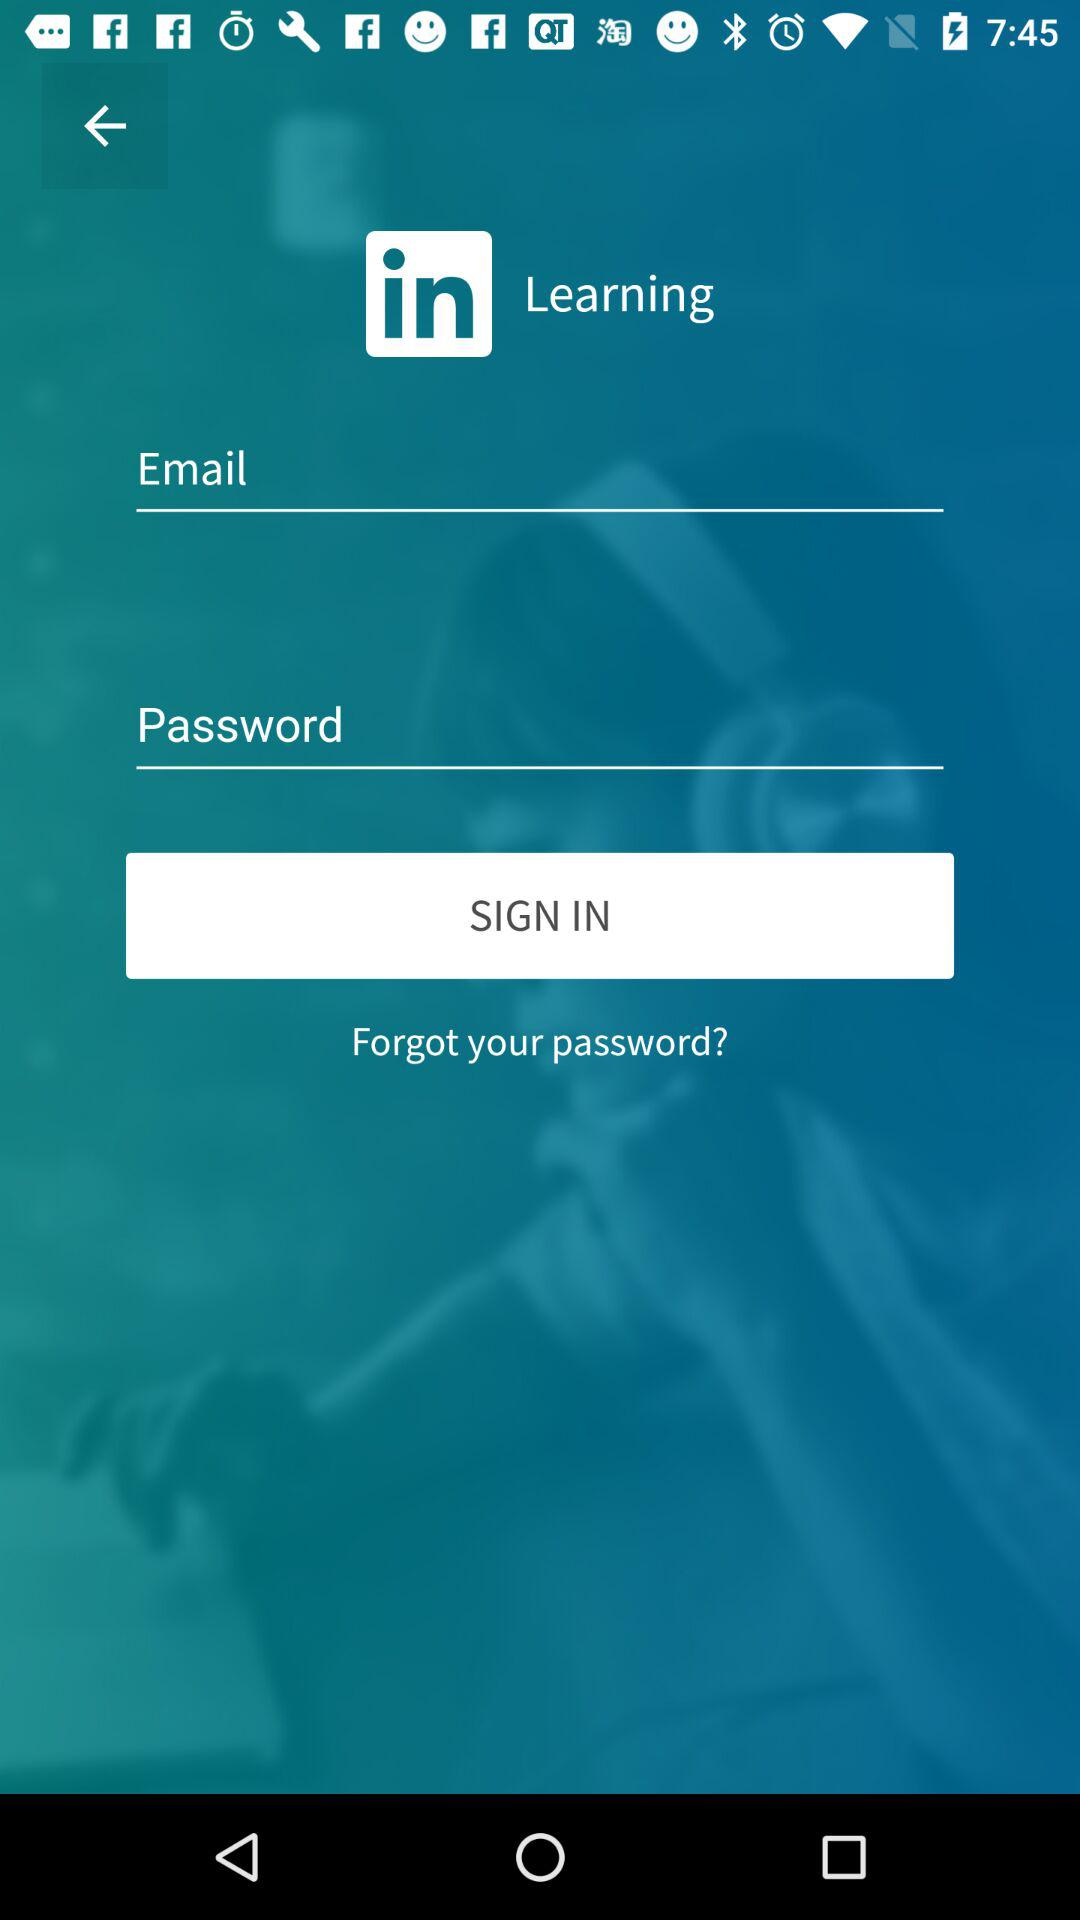What is the name of the application? The name of the application is "LinkedIn Learning". 